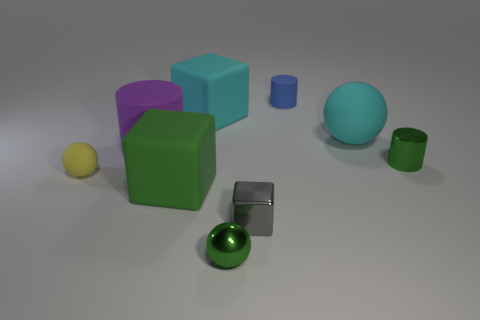There is a green thing that is the same shape as the purple object; what material is it?
Provide a short and direct response. Metal. How many objects are rubber spheres that are right of the yellow matte ball or big rubber spheres?
Give a very brief answer. 1. There is a tiny green object behind the big green cube; what is it made of?
Make the answer very short. Metal. What is the material of the tiny green sphere?
Your answer should be very brief. Metal. What material is the large cyan thing that is to the right of the small metal thing that is on the left side of the tiny shiny cube in front of the yellow matte thing?
Provide a succinct answer. Rubber. Are there any other things that are made of the same material as the cyan block?
Give a very brief answer. Yes. Is the size of the purple rubber thing the same as the cyan rubber object to the left of the small green metal ball?
Your answer should be very brief. Yes. How many objects are either cylinders right of the large purple rubber object or tiny things that are in front of the tiny gray block?
Your answer should be compact. 3. There is a rubber cube that is in front of the big cyan sphere; what color is it?
Offer a very short reply. Green. There is a cyan rubber thing that is to the left of the small blue rubber cylinder; are there any large cyan rubber objects in front of it?
Keep it short and to the point. Yes. 